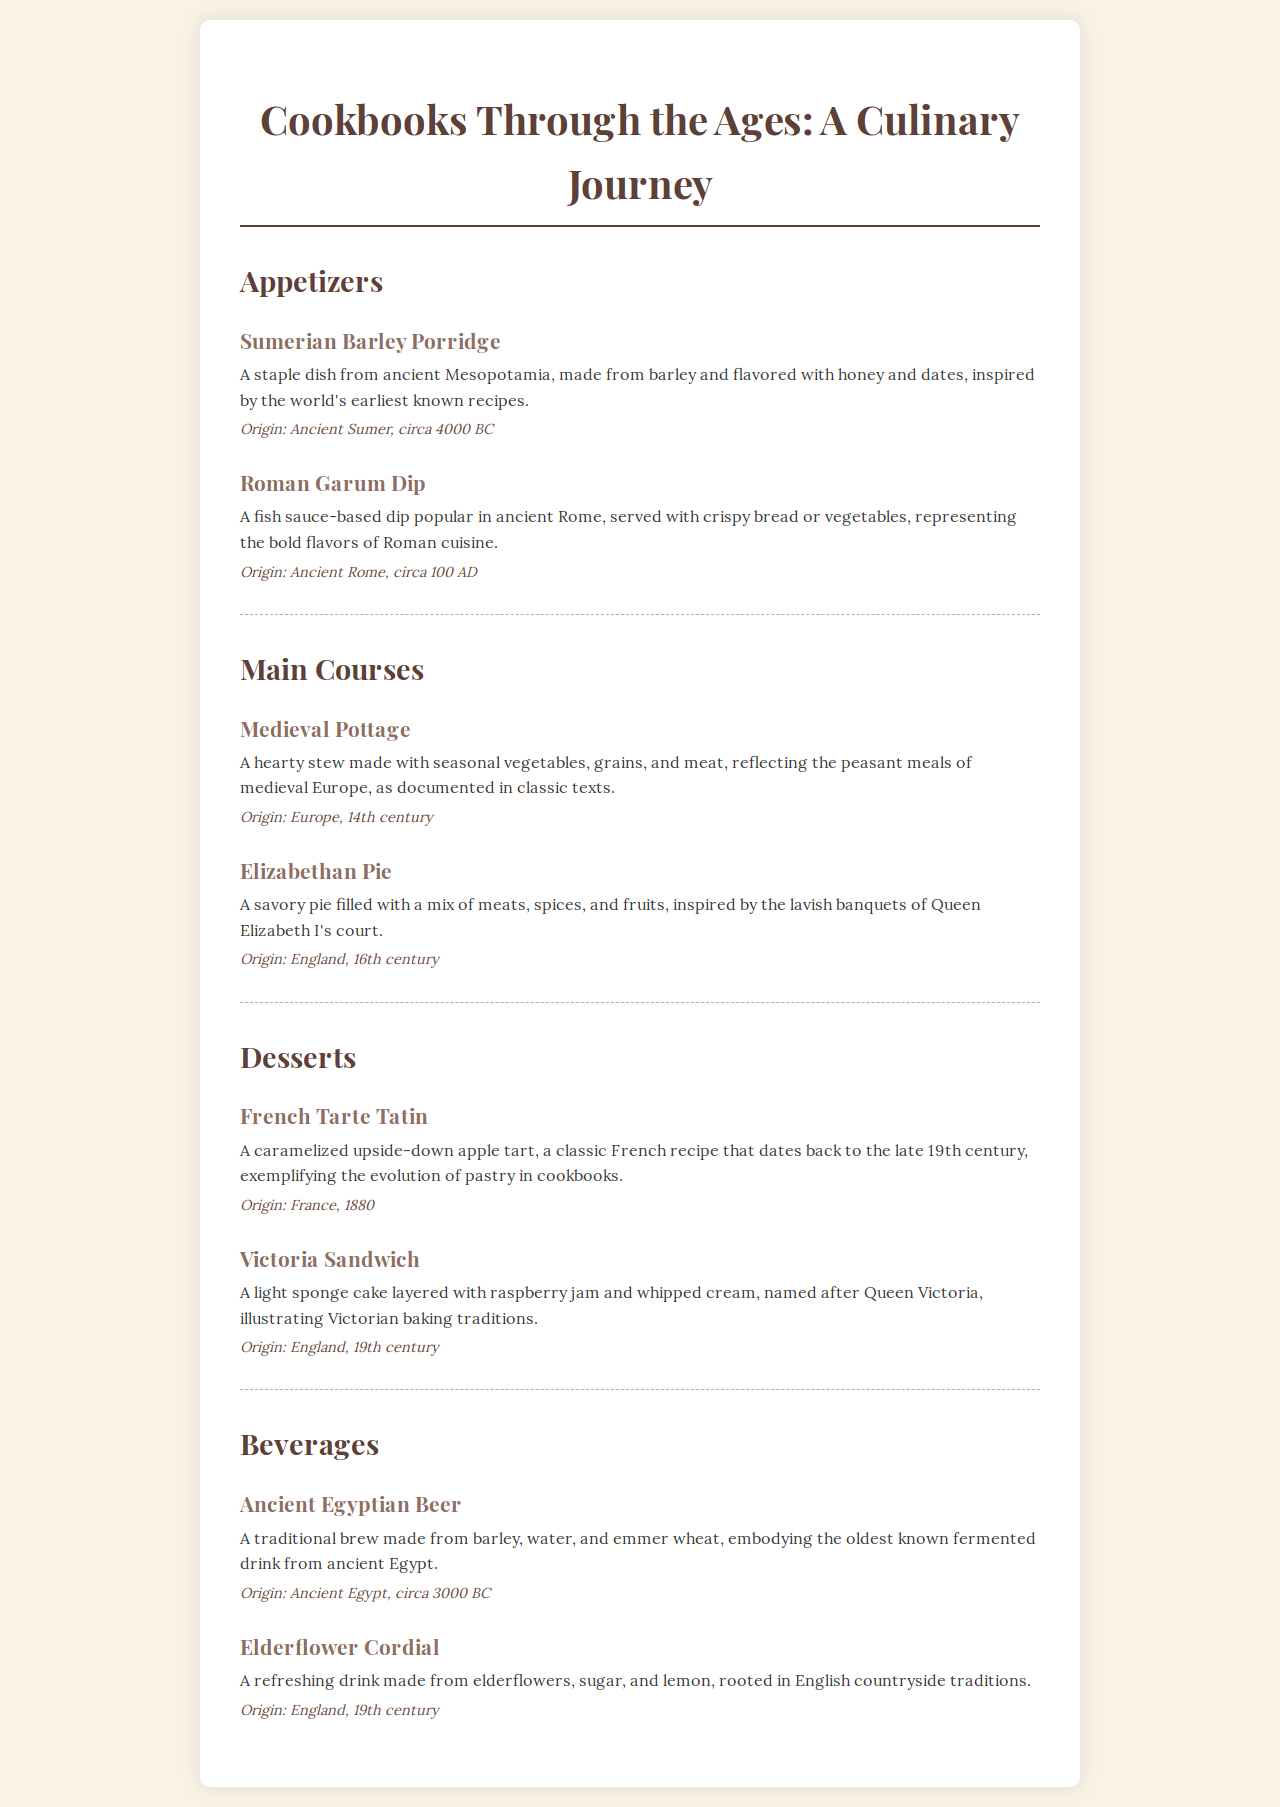What is the title of the menu? The title of the menu is stated at the top of the document.
Answer: Cookbooks Through the Ages: A Culinary Journey Where does Sumerian Barley Porridge originate from? The origin of Sumerian Barley Porridge is mentioned in its description.
Answer: Ancient Sumer, circa 4000 BC What is the main ingredient of the Roman Garum Dip? The main component of Roman Garum Dip is highlighted in the description.
Answer: Fish sauce Which century is the Medieval Pottage from? The document specifies the origin of Medieval Pottage in the introductory text.
Answer: 14th century What type of dish is the Elizabethan Pie? The description provides the type of dish it is classified as, highlighting its characteristics.
Answer: Savory pie How many desserts are listed in the menu? The number of desserts can be counted from the dessert section of the menu.
Answer: 2 What beverage is associated with Ancient Egypt? The beverage mentioned in relation to Ancient Egypt is specified in its description.
Answer: Beer What is the flavoring agent in Elderflower Cordial? The flavoring agent of Elderflower Cordial is referred to in the description.
Answer: Elderflowers 